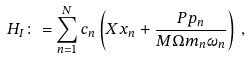<formula> <loc_0><loc_0><loc_500><loc_500>H _ { I } \colon = \sum _ { n = 1 } ^ { N } c _ { n } \left ( X x _ { n } + \frac { P p _ { n } } { M \Omega m _ { n } \omega _ { n } } \right ) \, ,</formula> 